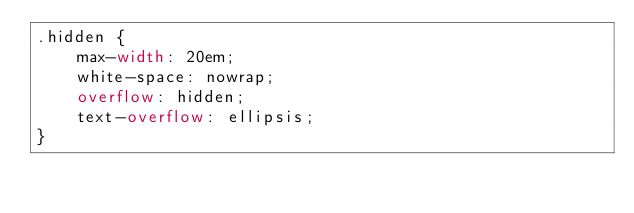<code> <loc_0><loc_0><loc_500><loc_500><_CSS_>.hidden {
    max-width: 20em;
    white-space: nowrap;
    overflow: hidden;
    text-overflow: ellipsis;
}
</code> 